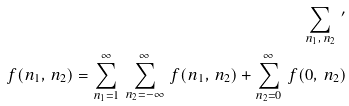<formula> <loc_0><loc_0><loc_500><loc_500>\sum _ { n _ { 1 } , \, n _ { 2 } } \, ^ { \prime } \\ f ( n _ { 1 } , \, n _ { 2 } ) = \sum _ { n _ { 1 } = 1 } ^ { \infty } \ \sum _ { n _ { 2 } = - \infty } ^ { \infty } \ f ( n _ { 1 } , \, n _ { 2 } ) + \sum _ { n _ { 2 } = 0 } ^ { \infty } \ f ( 0 , \, n _ { 2 } )</formula> 